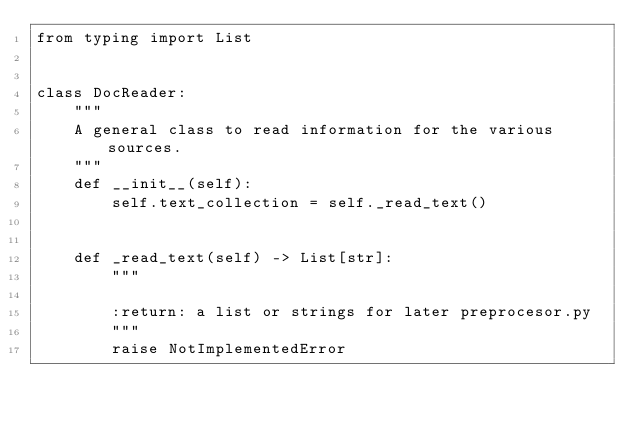Convert code to text. <code><loc_0><loc_0><loc_500><loc_500><_Python_>from typing import List


class DocReader:
    """
    A general class to read information for the various sources.
    """
    def __init__(self):
        self.text_collection = self._read_text()


    def _read_text(self) -> List[str]:
        """

        :return: a list or strings for later preprocesor.py
        """
        raise NotImplementedError
</code> 